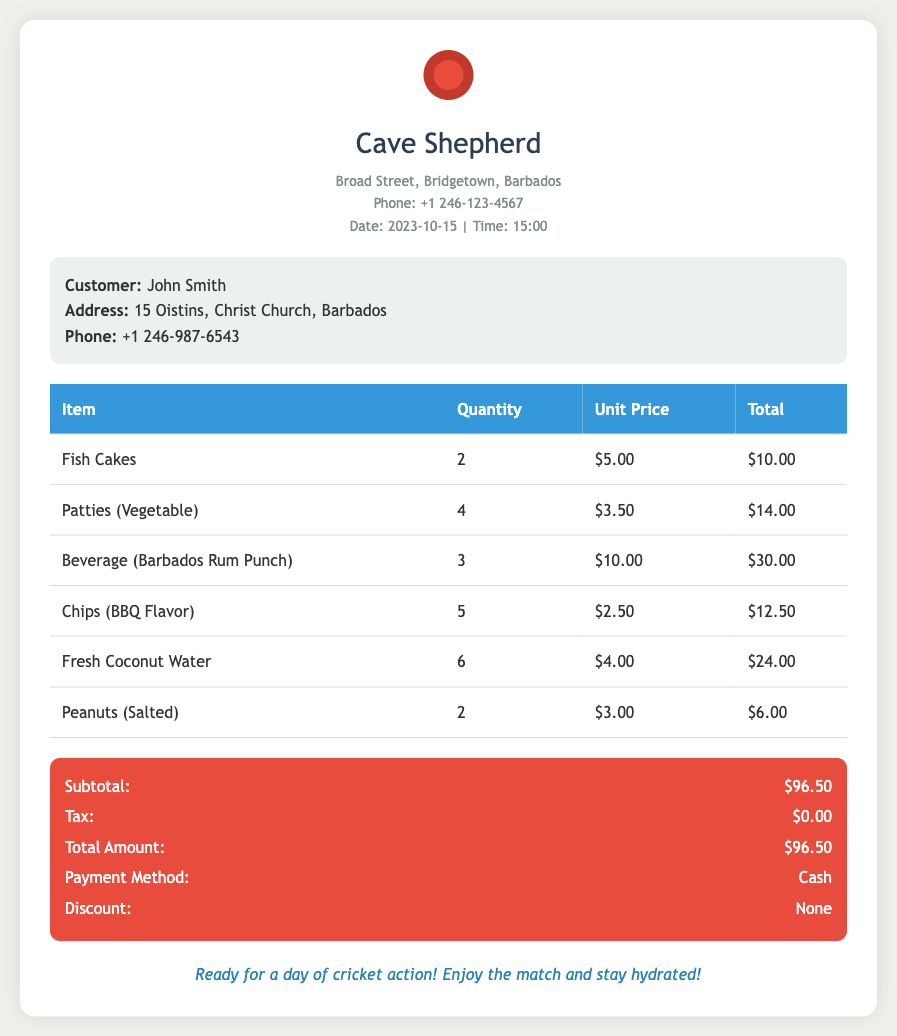What is the store name? The store name is prominently displayed at the top of the receipt.
Answer: Cave Shepherd What is the date of the transaction? The date of the transaction can be found in the store details section.
Answer: 2023-10-15 How many Fish Cakes were purchased? The number of Fish Cakes purchased is listed in the items table.
Answer: 2 What is the total amount spent? The total amount is provided at the end of the summary section.
Answer: $96.50 What payment method was used? The payment method is specified in the summary section of the receipt.
Answer: Cash How many items were purchased in total? The total number of items corresponds to the sum of all quantities in the items table.
Answer: 22 What was the unit price of Fresh Coconut Water? The unit price is listed in the items table next to Fresh Coconut Water.
Answer: $4.00 Where is the store located? The store location is included in the store details section at the top of the receipt.
Answer: Broad Street, Bridgetown, Barbados What type of beverage was purchased? The type of beverage can be found in the items table listing from the document.
Answer: Barbados Rum Punch 